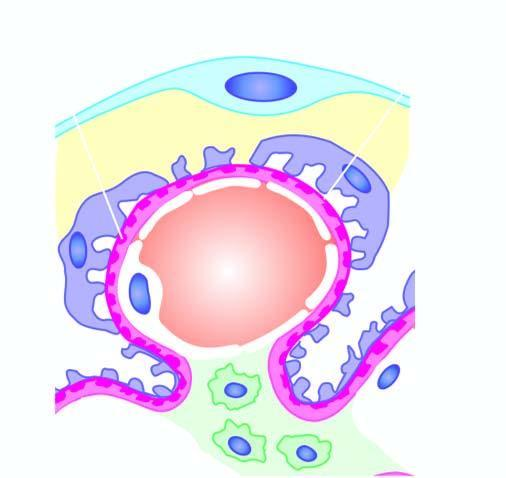does the basement membrane material protrude?
Answer the question using a single word or phrase. Yes 